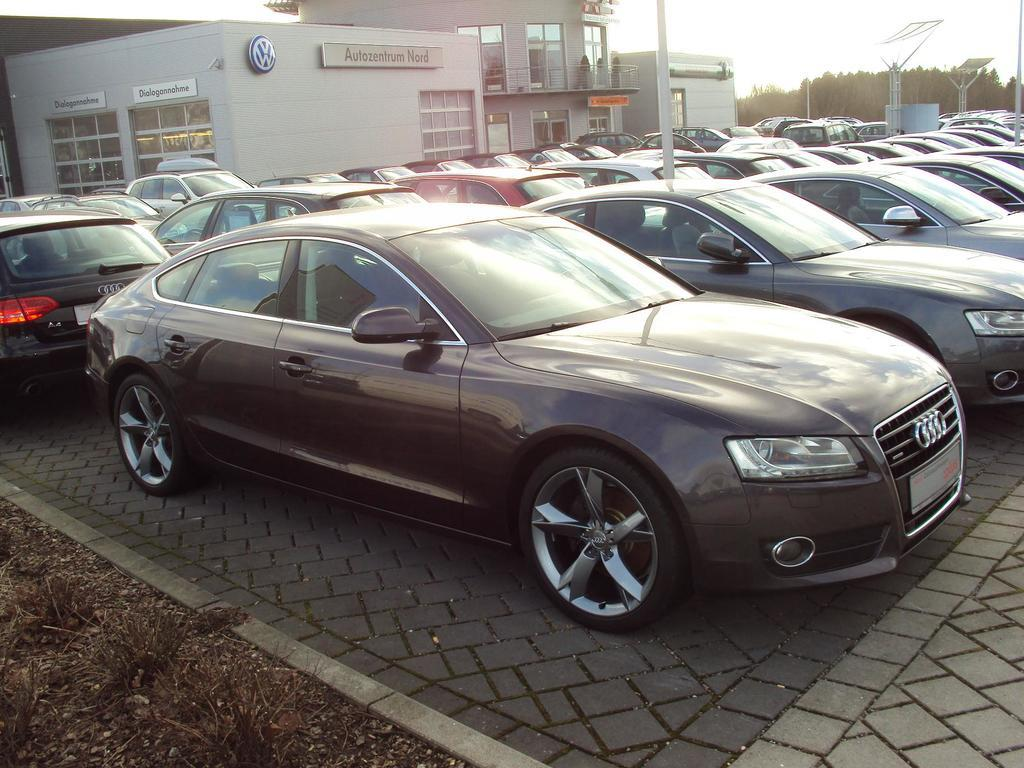What can be seen in the image that is used for transportation? There are cars parked in the image. What structure is visible in the background of the image? There is a building in the background of the image. What type of vegetation is on the right side of the image? There are trees on the right side of the image. What is the condition of the sky in the image? The sky is clear in the image. How many sponges are sitting on the cars in the image? There are no sponges present in the image; it features cars parked near a building and trees. What number is written on the building in the image? There is no number visible on the building in the image. 